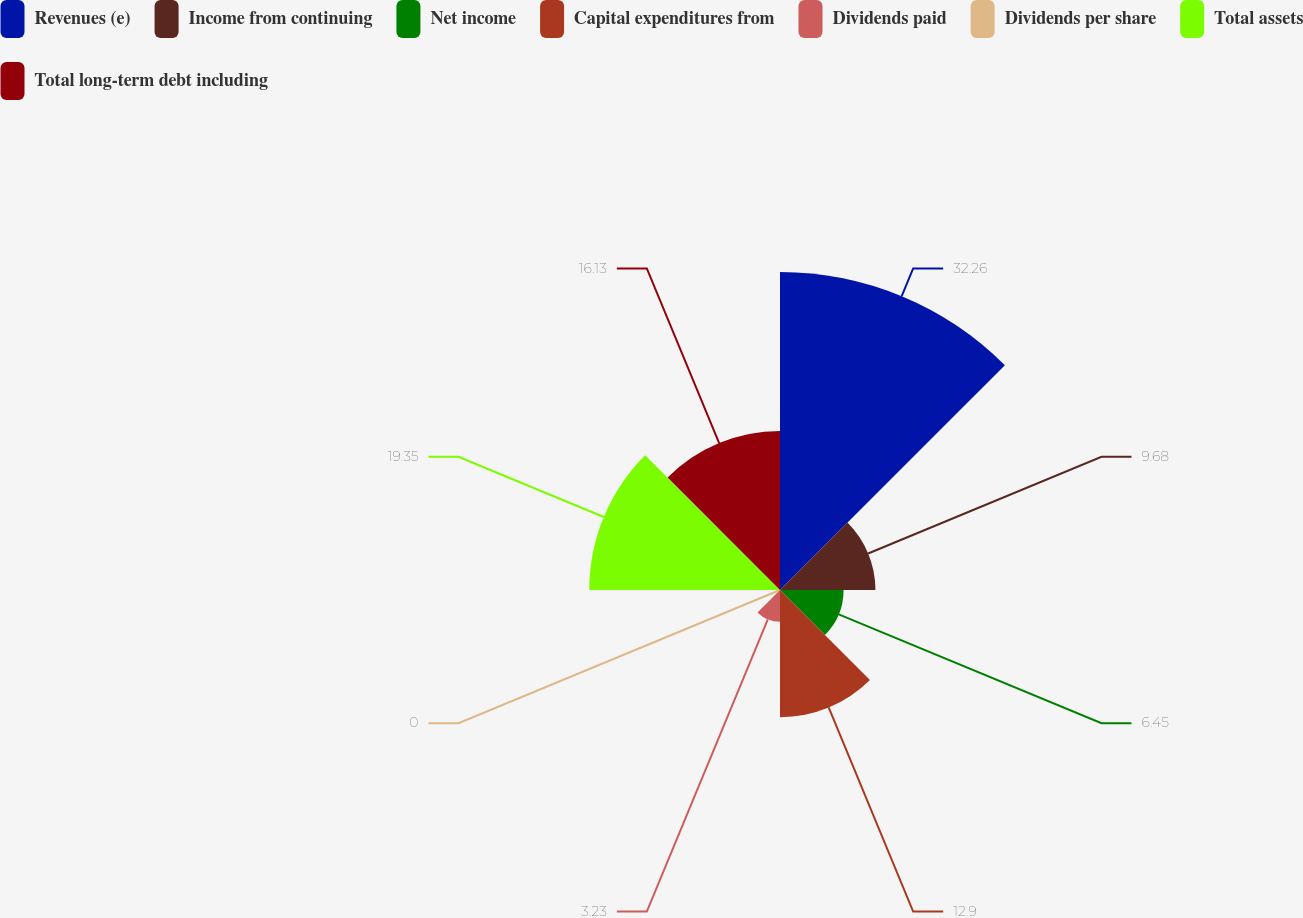<chart> <loc_0><loc_0><loc_500><loc_500><pie_chart><fcel>Revenues (e)<fcel>Income from continuing<fcel>Net income<fcel>Capital expenditures from<fcel>Dividends paid<fcel>Dividends per share<fcel>Total assets<fcel>Total long-term debt including<nl><fcel>32.26%<fcel>9.68%<fcel>6.45%<fcel>12.9%<fcel>3.23%<fcel>0.0%<fcel>19.35%<fcel>16.13%<nl></chart> 